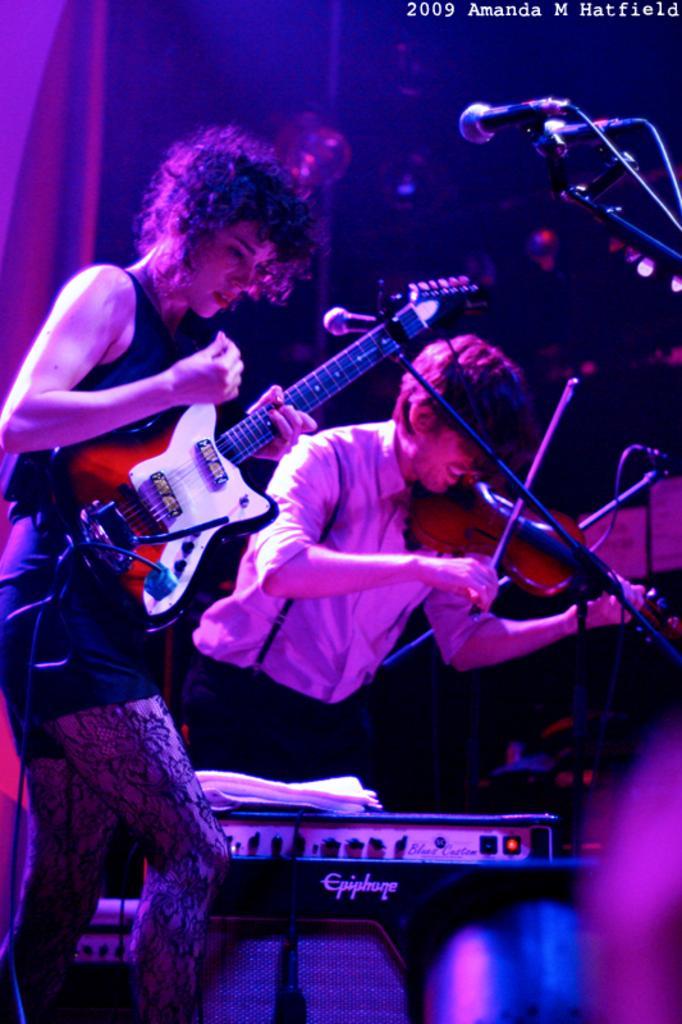In one or two sentences, can you explain what this image depicts? In this image we can see two persons playing musical instrument. On the right side, we can see mics with stands. At the bottom we can see an object. The background of the image is dark. 